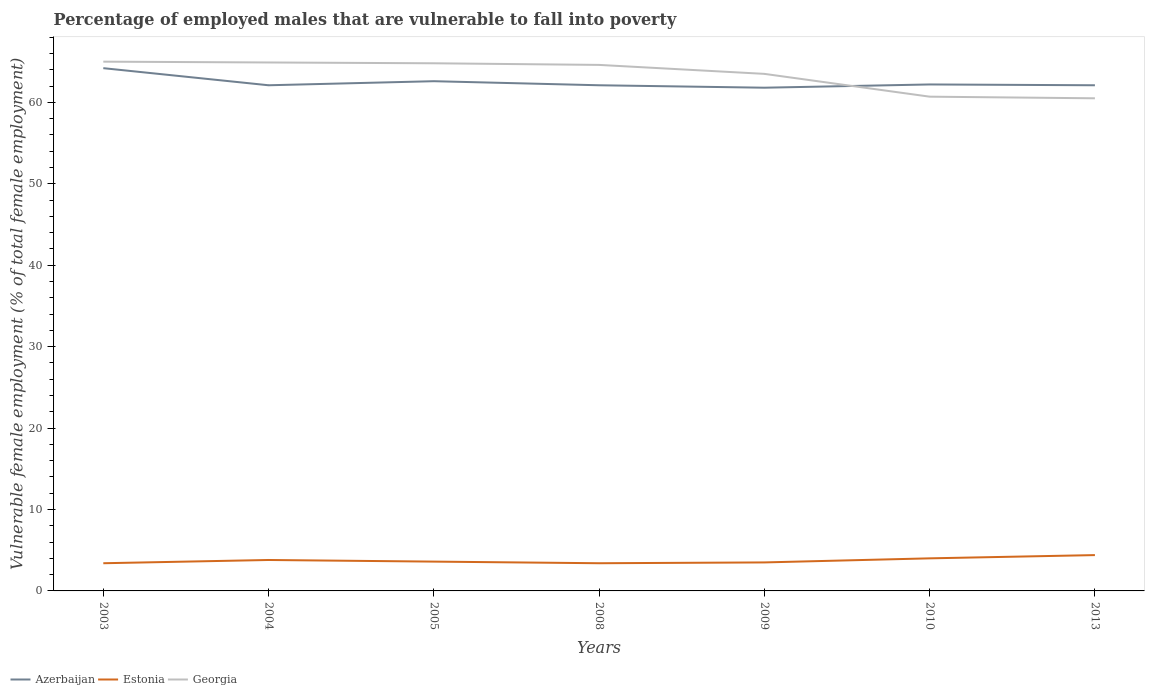How many different coloured lines are there?
Give a very brief answer. 3. Is the number of lines equal to the number of legend labels?
Offer a terse response. Yes. Across all years, what is the maximum percentage of employed males who are vulnerable to fall into poverty in Azerbaijan?
Give a very brief answer. 61.8. Is the percentage of employed males who are vulnerable to fall into poverty in Estonia strictly greater than the percentage of employed males who are vulnerable to fall into poverty in Georgia over the years?
Your answer should be compact. Yes. How many lines are there?
Your response must be concise. 3. Are the values on the major ticks of Y-axis written in scientific E-notation?
Provide a short and direct response. No. Does the graph contain grids?
Offer a very short reply. No. How many legend labels are there?
Your answer should be very brief. 3. How are the legend labels stacked?
Offer a terse response. Horizontal. What is the title of the graph?
Your answer should be very brief. Percentage of employed males that are vulnerable to fall into poverty. What is the label or title of the X-axis?
Provide a short and direct response. Years. What is the label or title of the Y-axis?
Provide a short and direct response. Vulnerable female employment (% of total female employment). What is the Vulnerable female employment (% of total female employment) in Azerbaijan in 2003?
Your response must be concise. 64.2. What is the Vulnerable female employment (% of total female employment) in Estonia in 2003?
Your response must be concise. 3.4. What is the Vulnerable female employment (% of total female employment) in Azerbaijan in 2004?
Keep it short and to the point. 62.1. What is the Vulnerable female employment (% of total female employment) of Estonia in 2004?
Provide a succinct answer. 3.8. What is the Vulnerable female employment (% of total female employment) in Georgia in 2004?
Offer a terse response. 64.9. What is the Vulnerable female employment (% of total female employment) of Azerbaijan in 2005?
Offer a very short reply. 62.6. What is the Vulnerable female employment (% of total female employment) of Estonia in 2005?
Provide a succinct answer. 3.6. What is the Vulnerable female employment (% of total female employment) in Georgia in 2005?
Provide a succinct answer. 64.8. What is the Vulnerable female employment (% of total female employment) in Azerbaijan in 2008?
Your answer should be very brief. 62.1. What is the Vulnerable female employment (% of total female employment) of Estonia in 2008?
Ensure brevity in your answer.  3.4. What is the Vulnerable female employment (% of total female employment) in Georgia in 2008?
Offer a terse response. 64.6. What is the Vulnerable female employment (% of total female employment) in Azerbaijan in 2009?
Your answer should be compact. 61.8. What is the Vulnerable female employment (% of total female employment) of Estonia in 2009?
Provide a short and direct response. 3.5. What is the Vulnerable female employment (% of total female employment) of Georgia in 2009?
Make the answer very short. 63.5. What is the Vulnerable female employment (% of total female employment) of Azerbaijan in 2010?
Ensure brevity in your answer.  62.2. What is the Vulnerable female employment (% of total female employment) of Georgia in 2010?
Your answer should be very brief. 60.7. What is the Vulnerable female employment (% of total female employment) in Azerbaijan in 2013?
Make the answer very short. 62.1. What is the Vulnerable female employment (% of total female employment) of Estonia in 2013?
Offer a very short reply. 4.4. What is the Vulnerable female employment (% of total female employment) of Georgia in 2013?
Offer a very short reply. 60.5. Across all years, what is the maximum Vulnerable female employment (% of total female employment) of Azerbaijan?
Ensure brevity in your answer.  64.2. Across all years, what is the maximum Vulnerable female employment (% of total female employment) of Estonia?
Your response must be concise. 4.4. Across all years, what is the minimum Vulnerable female employment (% of total female employment) of Azerbaijan?
Ensure brevity in your answer.  61.8. Across all years, what is the minimum Vulnerable female employment (% of total female employment) in Estonia?
Ensure brevity in your answer.  3.4. Across all years, what is the minimum Vulnerable female employment (% of total female employment) in Georgia?
Your response must be concise. 60.5. What is the total Vulnerable female employment (% of total female employment) in Azerbaijan in the graph?
Offer a very short reply. 437.1. What is the total Vulnerable female employment (% of total female employment) in Estonia in the graph?
Keep it short and to the point. 26.1. What is the total Vulnerable female employment (% of total female employment) of Georgia in the graph?
Offer a terse response. 444. What is the difference between the Vulnerable female employment (% of total female employment) in Estonia in 2003 and that in 2004?
Make the answer very short. -0.4. What is the difference between the Vulnerable female employment (% of total female employment) in Azerbaijan in 2003 and that in 2005?
Offer a terse response. 1.6. What is the difference between the Vulnerable female employment (% of total female employment) of Estonia in 2003 and that in 2005?
Ensure brevity in your answer.  -0.2. What is the difference between the Vulnerable female employment (% of total female employment) in Azerbaijan in 2003 and that in 2008?
Give a very brief answer. 2.1. What is the difference between the Vulnerable female employment (% of total female employment) of Georgia in 2003 and that in 2008?
Keep it short and to the point. 0.4. What is the difference between the Vulnerable female employment (% of total female employment) in Estonia in 2003 and that in 2009?
Make the answer very short. -0.1. What is the difference between the Vulnerable female employment (% of total female employment) in Azerbaijan in 2003 and that in 2010?
Make the answer very short. 2. What is the difference between the Vulnerable female employment (% of total female employment) in Georgia in 2003 and that in 2010?
Your response must be concise. 4.3. What is the difference between the Vulnerable female employment (% of total female employment) in Azerbaijan in 2004 and that in 2005?
Give a very brief answer. -0.5. What is the difference between the Vulnerable female employment (% of total female employment) in Estonia in 2004 and that in 2005?
Provide a short and direct response. 0.2. What is the difference between the Vulnerable female employment (% of total female employment) in Azerbaijan in 2004 and that in 2010?
Offer a terse response. -0.1. What is the difference between the Vulnerable female employment (% of total female employment) in Georgia in 2004 and that in 2010?
Provide a short and direct response. 4.2. What is the difference between the Vulnerable female employment (% of total female employment) of Georgia in 2004 and that in 2013?
Offer a terse response. 4.4. What is the difference between the Vulnerable female employment (% of total female employment) of Estonia in 2005 and that in 2008?
Ensure brevity in your answer.  0.2. What is the difference between the Vulnerable female employment (% of total female employment) in Azerbaijan in 2005 and that in 2009?
Make the answer very short. 0.8. What is the difference between the Vulnerable female employment (% of total female employment) in Estonia in 2005 and that in 2009?
Offer a very short reply. 0.1. What is the difference between the Vulnerable female employment (% of total female employment) of Georgia in 2005 and that in 2009?
Offer a terse response. 1.3. What is the difference between the Vulnerable female employment (% of total female employment) of Georgia in 2005 and that in 2010?
Make the answer very short. 4.1. What is the difference between the Vulnerable female employment (% of total female employment) of Azerbaijan in 2005 and that in 2013?
Ensure brevity in your answer.  0.5. What is the difference between the Vulnerable female employment (% of total female employment) in Azerbaijan in 2008 and that in 2009?
Make the answer very short. 0.3. What is the difference between the Vulnerable female employment (% of total female employment) of Georgia in 2008 and that in 2009?
Your response must be concise. 1.1. What is the difference between the Vulnerable female employment (% of total female employment) of Estonia in 2008 and that in 2010?
Your answer should be compact. -0.6. What is the difference between the Vulnerable female employment (% of total female employment) of Georgia in 2008 and that in 2010?
Ensure brevity in your answer.  3.9. What is the difference between the Vulnerable female employment (% of total female employment) in Estonia in 2008 and that in 2013?
Make the answer very short. -1. What is the difference between the Vulnerable female employment (% of total female employment) in Azerbaijan in 2009 and that in 2010?
Make the answer very short. -0.4. What is the difference between the Vulnerable female employment (% of total female employment) of Georgia in 2009 and that in 2010?
Make the answer very short. 2.8. What is the difference between the Vulnerable female employment (% of total female employment) in Georgia in 2009 and that in 2013?
Ensure brevity in your answer.  3. What is the difference between the Vulnerable female employment (% of total female employment) of Azerbaijan in 2010 and that in 2013?
Make the answer very short. 0.1. What is the difference between the Vulnerable female employment (% of total female employment) of Estonia in 2010 and that in 2013?
Your answer should be very brief. -0.4. What is the difference between the Vulnerable female employment (% of total female employment) in Azerbaijan in 2003 and the Vulnerable female employment (% of total female employment) in Estonia in 2004?
Offer a terse response. 60.4. What is the difference between the Vulnerable female employment (% of total female employment) in Azerbaijan in 2003 and the Vulnerable female employment (% of total female employment) in Georgia in 2004?
Your answer should be very brief. -0.7. What is the difference between the Vulnerable female employment (% of total female employment) in Estonia in 2003 and the Vulnerable female employment (% of total female employment) in Georgia in 2004?
Offer a terse response. -61.5. What is the difference between the Vulnerable female employment (% of total female employment) in Azerbaijan in 2003 and the Vulnerable female employment (% of total female employment) in Estonia in 2005?
Make the answer very short. 60.6. What is the difference between the Vulnerable female employment (% of total female employment) in Azerbaijan in 2003 and the Vulnerable female employment (% of total female employment) in Georgia in 2005?
Ensure brevity in your answer.  -0.6. What is the difference between the Vulnerable female employment (% of total female employment) in Estonia in 2003 and the Vulnerable female employment (% of total female employment) in Georgia in 2005?
Ensure brevity in your answer.  -61.4. What is the difference between the Vulnerable female employment (% of total female employment) in Azerbaijan in 2003 and the Vulnerable female employment (% of total female employment) in Estonia in 2008?
Make the answer very short. 60.8. What is the difference between the Vulnerable female employment (% of total female employment) in Azerbaijan in 2003 and the Vulnerable female employment (% of total female employment) in Georgia in 2008?
Offer a very short reply. -0.4. What is the difference between the Vulnerable female employment (% of total female employment) in Estonia in 2003 and the Vulnerable female employment (% of total female employment) in Georgia in 2008?
Provide a short and direct response. -61.2. What is the difference between the Vulnerable female employment (% of total female employment) in Azerbaijan in 2003 and the Vulnerable female employment (% of total female employment) in Estonia in 2009?
Offer a terse response. 60.7. What is the difference between the Vulnerable female employment (% of total female employment) of Estonia in 2003 and the Vulnerable female employment (% of total female employment) of Georgia in 2009?
Keep it short and to the point. -60.1. What is the difference between the Vulnerable female employment (% of total female employment) of Azerbaijan in 2003 and the Vulnerable female employment (% of total female employment) of Estonia in 2010?
Offer a very short reply. 60.2. What is the difference between the Vulnerable female employment (% of total female employment) of Azerbaijan in 2003 and the Vulnerable female employment (% of total female employment) of Georgia in 2010?
Offer a terse response. 3.5. What is the difference between the Vulnerable female employment (% of total female employment) of Estonia in 2003 and the Vulnerable female employment (% of total female employment) of Georgia in 2010?
Your response must be concise. -57.3. What is the difference between the Vulnerable female employment (% of total female employment) of Azerbaijan in 2003 and the Vulnerable female employment (% of total female employment) of Estonia in 2013?
Make the answer very short. 59.8. What is the difference between the Vulnerable female employment (% of total female employment) of Estonia in 2003 and the Vulnerable female employment (% of total female employment) of Georgia in 2013?
Your answer should be very brief. -57.1. What is the difference between the Vulnerable female employment (% of total female employment) of Azerbaijan in 2004 and the Vulnerable female employment (% of total female employment) of Estonia in 2005?
Offer a terse response. 58.5. What is the difference between the Vulnerable female employment (% of total female employment) of Azerbaijan in 2004 and the Vulnerable female employment (% of total female employment) of Georgia in 2005?
Make the answer very short. -2.7. What is the difference between the Vulnerable female employment (% of total female employment) of Estonia in 2004 and the Vulnerable female employment (% of total female employment) of Georgia in 2005?
Make the answer very short. -61. What is the difference between the Vulnerable female employment (% of total female employment) in Azerbaijan in 2004 and the Vulnerable female employment (% of total female employment) in Estonia in 2008?
Offer a terse response. 58.7. What is the difference between the Vulnerable female employment (% of total female employment) in Azerbaijan in 2004 and the Vulnerable female employment (% of total female employment) in Georgia in 2008?
Ensure brevity in your answer.  -2.5. What is the difference between the Vulnerable female employment (% of total female employment) in Estonia in 2004 and the Vulnerable female employment (% of total female employment) in Georgia in 2008?
Provide a succinct answer. -60.8. What is the difference between the Vulnerable female employment (% of total female employment) in Azerbaijan in 2004 and the Vulnerable female employment (% of total female employment) in Estonia in 2009?
Keep it short and to the point. 58.6. What is the difference between the Vulnerable female employment (% of total female employment) in Azerbaijan in 2004 and the Vulnerable female employment (% of total female employment) in Georgia in 2009?
Offer a terse response. -1.4. What is the difference between the Vulnerable female employment (% of total female employment) of Estonia in 2004 and the Vulnerable female employment (% of total female employment) of Georgia in 2009?
Keep it short and to the point. -59.7. What is the difference between the Vulnerable female employment (% of total female employment) of Azerbaijan in 2004 and the Vulnerable female employment (% of total female employment) of Estonia in 2010?
Make the answer very short. 58.1. What is the difference between the Vulnerable female employment (% of total female employment) in Azerbaijan in 2004 and the Vulnerable female employment (% of total female employment) in Georgia in 2010?
Your response must be concise. 1.4. What is the difference between the Vulnerable female employment (% of total female employment) of Estonia in 2004 and the Vulnerable female employment (% of total female employment) of Georgia in 2010?
Provide a succinct answer. -56.9. What is the difference between the Vulnerable female employment (% of total female employment) of Azerbaijan in 2004 and the Vulnerable female employment (% of total female employment) of Estonia in 2013?
Give a very brief answer. 57.7. What is the difference between the Vulnerable female employment (% of total female employment) in Estonia in 2004 and the Vulnerable female employment (% of total female employment) in Georgia in 2013?
Provide a short and direct response. -56.7. What is the difference between the Vulnerable female employment (% of total female employment) in Azerbaijan in 2005 and the Vulnerable female employment (% of total female employment) in Estonia in 2008?
Your answer should be compact. 59.2. What is the difference between the Vulnerable female employment (% of total female employment) in Estonia in 2005 and the Vulnerable female employment (% of total female employment) in Georgia in 2008?
Provide a succinct answer. -61. What is the difference between the Vulnerable female employment (% of total female employment) of Azerbaijan in 2005 and the Vulnerable female employment (% of total female employment) of Estonia in 2009?
Make the answer very short. 59.1. What is the difference between the Vulnerable female employment (% of total female employment) in Azerbaijan in 2005 and the Vulnerable female employment (% of total female employment) in Georgia in 2009?
Offer a terse response. -0.9. What is the difference between the Vulnerable female employment (% of total female employment) of Estonia in 2005 and the Vulnerable female employment (% of total female employment) of Georgia in 2009?
Your answer should be very brief. -59.9. What is the difference between the Vulnerable female employment (% of total female employment) in Azerbaijan in 2005 and the Vulnerable female employment (% of total female employment) in Estonia in 2010?
Your answer should be very brief. 58.6. What is the difference between the Vulnerable female employment (% of total female employment) in Azerbaijan in 2005 and the Vulnerable female employment (% of total female employment) in Georgia in 2010?
Offer a terse response. 1.9. What is the difference between the Vulnerable female employment (% of total female employment) in Estonia in 2005 and the Vulnerable female employment (% of total female employment) in Georgia in 2010?
Offer a terse response. -57.1. What is the difference between the Vulnerable female employment (% of total female employment) of Azerbaijan in 2005 and the Vulnerable female employment (% of total female employment) of Estonia in 2013?
Ensure brevity in your answer.  58.2. What is the difference between the Vulnerable female employment (% of total female employment) in Estonia in 2005 and the Vulnerable female employment (% of total female employment) in Georgia in 2013?
Make the answer very short. -56.9. What is the difference between the Vulnerable female employment (% of total female employment) of Azerbaijan in 2008 and the Vulnerable female employment (% of total female employment) of Estonia in 2009?
Provide a short and direct response. 58.6. What is the difference between the Vulnerable female employment (% of total female employment) of Estonia in 2008 and the Vulnerable female employment (% of total female employment) of Georgia in 2009?
Provide a succinct answer. -60.1. What is the difference between the Vulnerable female employment (% of total female employment) in Azerbaijan in 2008 and the Vulnerable female employment (% of total female employment) in Estonia in 2010?
Keep it short and to the point. 58.1. What is the difference between the Vulnerable female employment (% of total female employment) of Azerbaijan in 2008 and the Vulnerable female employment (% of total female employment) of Georgia in 2010?
Give a very brief answer. 1.4. What is the difference between the Vulnerable female employment (% of total female employment) in Estonia in 2008 and the Vulnerable female employment (% of total female employment) in Georgia in 2010?
Keep it short and to the point. -57.3. What is the difference between the Vulnerable female employment (% of total female employment) of Azerbaijan in 2008 and the Vulnerable female employment (% of total female employment) of Estonia in 2013?
Provide a short and direct response. 57.7. What is the difference between the Vulnerable female employment (% of total female employment) of Estonia in 2008 and the Vulnerable female employment (% of total female employment) of Georgia in 2013?
Offer a very short reply. -57.1. What is the difference between the Vulnerable female employment (% of total female employment) in Azerbaijan in 2009 and the Vulnerable female employment (% of total female employment) in Estonia in 2010?
Offer a terse response. 57.8. What is the difference between the Vulnerable female employment (% of total female employment) in Azerbaijan in 2009 and the Vulnerable female employment (% of total female employment) in Georgia in 2010?
Your answer should be very brief. 1.1. What is the difference between the Vulnerable female employment (% of total female employment) in Estonia in 2009 and the Vulnerable female employment (% of total female employment) in Georgia in 2010?
Give a very brief answer. -57.2. What is the difference between the Vulnerable female employment (% of total female employment) of Azerbaijan in 2009 and the Vulnerable female employment (% of total female employment) of Estonia in 2013?
Make the answer very short. 57.4. What is the difference between the Vulnerable female employment (% of total female employment) in Estonia in 2009 and the Vulnerable female employment (% of total female employment) in Georgia in 2013?
Your answer should be very brief. -57. What is the difference between the Vulnerable female employment (% of total female employment) in Azerbaijan in 2010 and the Vulnerable female employment (% of total female employment) in Estonia in 2013?
Give a very brief answer. 57.8. What is the difference between the Vulnerable female employment (% of total female employment) in Estonia in 2010 and the Vulnerable female employment (% of total female employment) in Georgia in 2013?
Make the answer very short. -56.5. What is the average Vulnerable female employment (% of total female employment) of Azerbaijan per year?
Give a very brief answer. 62.44. What is the average Vulnerable female employment (% of total female employment) of Estonia per year?
Keep it short and to the point. 3.73. What is the average Vulnerable female employment (% of total female employment) in Georgia per year?
Offer a very short reply. 63.43. In the year 2003, what is the difference between the Vulnerable female employment (% of total female employment) of Azerbaijan and Vulnerable female employment (% of total female employment) of Estonia?
Your answer should be very brief. 60.8. In the year 2003, what is the difference between the Vulnerable female employment (% of total female employment) of Azerbaijan and Vulnerable female employment (% of total female employment) of Georgia?
Keep it short and to the point. -0.8. In the year 2003, what is the difference between the Vulnerable female employment (% of total female employment) of Estonia and Vulnerable female employment (% of total female employment) of Georgia?
Your response must be concise. -61.6. In the year 2004, what is the difference between the Vulnerable female employment (% of total female employment) of Azerbaijan and Vulnerable female employment (% of total female employment) of Estonia?
Ensure brevity in your answer.  58.3. In the year 2004, what is the difference between the Vulnerable female employment (% of total female employment) of Azerbaijan and Vulnerable female employment (% of total female employment) of Georgia?
Offer a terse response. -2.8. In the year 2004, what is the difference between the Vulnerable female employment (% of total female employment) of Estonia and Vulnerable female employment (% of total female employment) of Georgia?
Your answer should be compact. -61.1. In the year 2005, what is the difference between the Vulnerable female employment (% of total female employment) in Azerbaijan and Vulnerable female employment (% of total female employment) in Georgia?
Keep it short and to the point. -2.2. In the year 2005, what is the difference between the Vulnerable female employment (% of total female employment) in Estonia and Vulnerable female employment (% of total female employment) in Georgia?
Your answer should be compact. -61.2. In the year 2008, what is the difference between the Vulnerable female employment (% of total female employment) in Azerbaijan and Vulnerable female employment (% of total female employment) in Estonia?
Keep it short and to the point. 58.7. In the year 2008, what is the difference between the Vulnerable female employment (% of total female employment) in Estonia and Vulnerable female employment (% of total female employment) in Georgia?
Your answer should be very brief. -61.2. In the year 2009, what is the difference between the Vulnerable female employment (% of total female employment) in Azerbaijan and Vulnerable female employment (% of total female employment) in Estonia?
Keep it short and to the point. 58.3. In the year 2009, what is the difference between the Vulnerable female employment (% of total female employment) in Estonia and Vulnerable female employment (% of total female employment) in Georgia?
Provide a short and direct response. -60. In the year 2010, what is the difference between the Vulnerable female employment (% of total female employment) in Azerbaijan and Vulnerable female employment (% of total female employment) in Estonia?
Your answer should be very brief. 58.2. In the year 2010, what is the difference between the Vulnerable female employment (% of total female employment) of Estonia and Vulnerable female employment (% of total female employment) of Georgia?
Ensure brevity in your answer.  -56.7. In the year 2013, what is the difference between the Vulnerable female employment (% of total female employment) of Azerbaijan and Vulnerable female employment (% of total female employment) of Estonia?
Your answer should be very brief. 57.7. In the year 2013, what is the difference between the Vulnerable female employment (% of total female employment) in Azerbaijan and Vulnerable female employment (% of total female employment) in Georgia?
Provide a short and direct response. 1.6. In the year 2013, what is the difference between the Vulnerable female employment (% of total female employment) of Estonia and Vulnerable female employment (% of total female employment) of Georgia?
Give a very brief answer. -56.1. What is the ratio of the Vulnerable female employment (% of total female employment) in Azerbaijan in 2003 to that in 2004?
Offer a very short reply. 1.03. What is the ratio of the Vulnerable female employment (% of total female employment) of Estonia in 2003 to that in 2004?
Make the answer very short. 0.89. What is the ratio of the Vulnerable female employment (% of total female employment) of Azerbaijan in 2003 to that in 2005?
Your response must be concise. 1.03. What is the ratio of the Vulnerable female employment (% of total female employment) in Estonia in 2003 to that in 2005?
Your answer should be compact. 0.94. What is the ratio of the Vulnerable female employment (% of total female employment) of Azerbaijan in 2003 to that in 2008?
Make the answer very short. 1.03. What is the ratio of the Vulnerable female employment (% of total female employment) of Estonia in 2003 to that in 2008?
Provide a short and direct response. 1. What is the ratio of the Vulnerable female employment (% of total female employment) in Azerbaijan in 2003 to that in 2009?
Your answer should be very brief. 1.04. What is the ratio of the Vulnerable female employment (% of total female employment) in Estonia in 2003 to that in 2009?
Make the answer very short. 0.97. What is the ratio of the Vulnerable female employment (% of total female employment) in Georgia in 2003 to that in 2009?
Your answer should be compact. 1.02. What is the ratio of the Vulnerable female employment (% of total female employment) of Azerbaijan in 2003 to that in 2010?
Make the answer very short. 1.03. What is the ratio of the Vulnerable female employment (% of total female employment) of Estonia in 2003 to that in 2010?
Give a very brief answer. 0.85. What is the ratio of the Vulnerable female employment (% of total female employment) in Georgia in 2003 to that in 2010?
Your response must be concise. 1.07. What is the ratio of the Vulnerable female employment (% of total female employment) in Azerbaijan in 2003 to that in 2013?
Keep it short and to the point. 1.03. What is the ratio of the Vulnerable female employment (% of total female employment) in Estonia in 2003 to that in 2013?
Your answer should be compact. 0.77. What is the ratio of the Vulnerable female employment (% of total female employment) in Georgia in 2003 to that in 2013?
Offer a very short reply. 1.07. What is the ratio of the Vulnerable female employment (% of total female employment) of Estonia in 2004 to that in 2005?
Ensure brevity in your answer.  1.06. What is the ratio of the Vulnerable female employment (% of total female employment) of Georgia in 2004 to that in 2005?
Offer a terse response. 1. What is the ratio of the Vulnerable female employment (% of total female employment) in Estonia in 2004 to that in 2008?
Your answer should be compact. 1.12. What is the ratio of the Vulnerable female employment (% of total female employment) in Estonia in 2004 to that in 2009?
Your response must be concise. 1.09. What is the ratio of the Vulnerable female employment (% of total female employment) in Georgia in 2004 to that in 2009?
Your answer should be compact. 1.02. What is the ratio of the Vulnerable female employment (% of total female employment) of Estonia in 2004 to that in 2010?
Provide a succinct answer. 0.95. What is the ratio of the Vulnerable female employment (% of total female employment) of Georgia in 2004 to that in 2010?
Offer a very short reply. 1.07. What is the ratio of the Vulnerable female employment (% of total female employment) in Azerbaijan in 2004 to that in 2013?
Provide a short and direct response. 1. What is the ratio of the Vulnerable female employment (% of total female employment) of Estonia in 2004 to that in 2013?
Make the answer very short. 0.86. What is the ratio of the Vulnerable female employment (% of total female employment) in Georgia in 2004 to that in 2013?
Your answer should be compact. 1.07. What is the ratio of the Vulnerable female employment (% of total female employment) in Azerbaijan in 2005 to that in 2008?
Keep it short and to the point. 1.01. What is the ratio of the Vulnerable female employment (% of total female employment) of Estonia in 2005 to that in 2008?
Ensure brevity in your answer.  1.06. What is the ratio of the Vulnerable female employment (% of total female employment) of Azerbaijan in 2005 to that in 2009?
Make the answer very short. 1.01. What is the ratio of the Vulnerable female employment (% of total female employment) in Estonia in 2005 to that in 2009?
Offer a terse response. 1.03. What is the ratio of the Vulnerable female employment (% of total female employment) of Georgia in 2005 to that in 2009?
Give a very brief answer. 1.02. What is the ratio of the Vulnerable female employment (% of total female employment) in Azerbaijan in 2005 to that in 2010?
Your response must be concise. 1.01. What is the ratio of the Vulnerable female employment (% of total female employment) of Estonia in 2005 to that in 2010?
Offer a very short reply. 0.9. What is the ratio of the Vulnerable female employment (% of total female employment) in Georgia in 2005 to that in 2010?
Your response must be concise. 1.07. What is the ratio of the Vulnerable female employment (% of total female employment) of Azerbaijan in 2005 to that in 2013?
Offer a very short reply. 1.01. What is the ratio of the Vulnerable female employment (% of total female employment) in Estonia in 2005 to that in 2013?
Keep it short and to the point. 0.82. What is the ratio of the Vulnerable female employment (% of total female employment) of Georgia in 2005 to that in 2013?
Offer a terse response. 1.07. What is the ratio of the Vulnerable female employment (% of total female employment) in Estonia in 2008 to that in 2009?
Offer a terse response. 0.97. What is the ratio of the Vulnerable female employment (% of total female employment) of Georgia in 2008 to that in 2009?
Give a very brief answer. 1.02. What is the ratio of the Vulnerable female employment (% of total female employment) of Azerbaijan in 2008 to that in 2010?
Your response must be concise. 1. What is the ratio of the Vulnerable female employment (% of total female employment) in Georgia in 2008 to that in 2010?
Give a very brief answer. 1.06. What is the ratio of the Vulnerable female employment (% of total female employment) in Estonia in 2008 to that in 2013?
Give a very brief answer. 0.77. What is the ratio of the Vulnerable female employment (% of total female employment) of Georgia in 2008 to that in 2013?
Give a very brief answer. 1.07. What is the ratio of the Vulnerable female employment (% of total female employment) in Azerbaijan in 2009 to that in 2010?
Provide a succinct answer. 0.99. What is the ratio of the Vulnerable female employment (% of total female employment) of Estonia in 2009 to that in 2010?
Offer a terse response. 0.88. What is the ratio of the Vulnerable female employment (% of total female employment) in Georgia in 2009 to that in 2010?
Make the answer very short. 1.05. What is the ratio of the Vulnerable female employment (% of total female employment) of Estonia in 2009 to that in 2013?
Keep it short and to the point. 0.8. What is the ratio of the Vulnerable female employment (% of total female employment) in Georgia in 2009 to that in 2013?
Provide a short and direct response. 1.05. What is the difference between the highest and the second highest Vulnerable female employment (% of total female employment) of Azerbaijan?
Make the answer very short. 1.6. What is the difference between the highest and the second highest Vulnerable female employment (% of total female employment) of Estonia?
Give a very brief answer. 0.4. What is the difference between the highest and the second highest Vulnerable female employment (% of total female employment) of Georgia?
Keep it short and to the point. 0.1. What is the difference between the highest and the lowest Vulnerable female employment (% of total female employment) in Azerbaijan?
Your answer should be very brief. 2.4. 